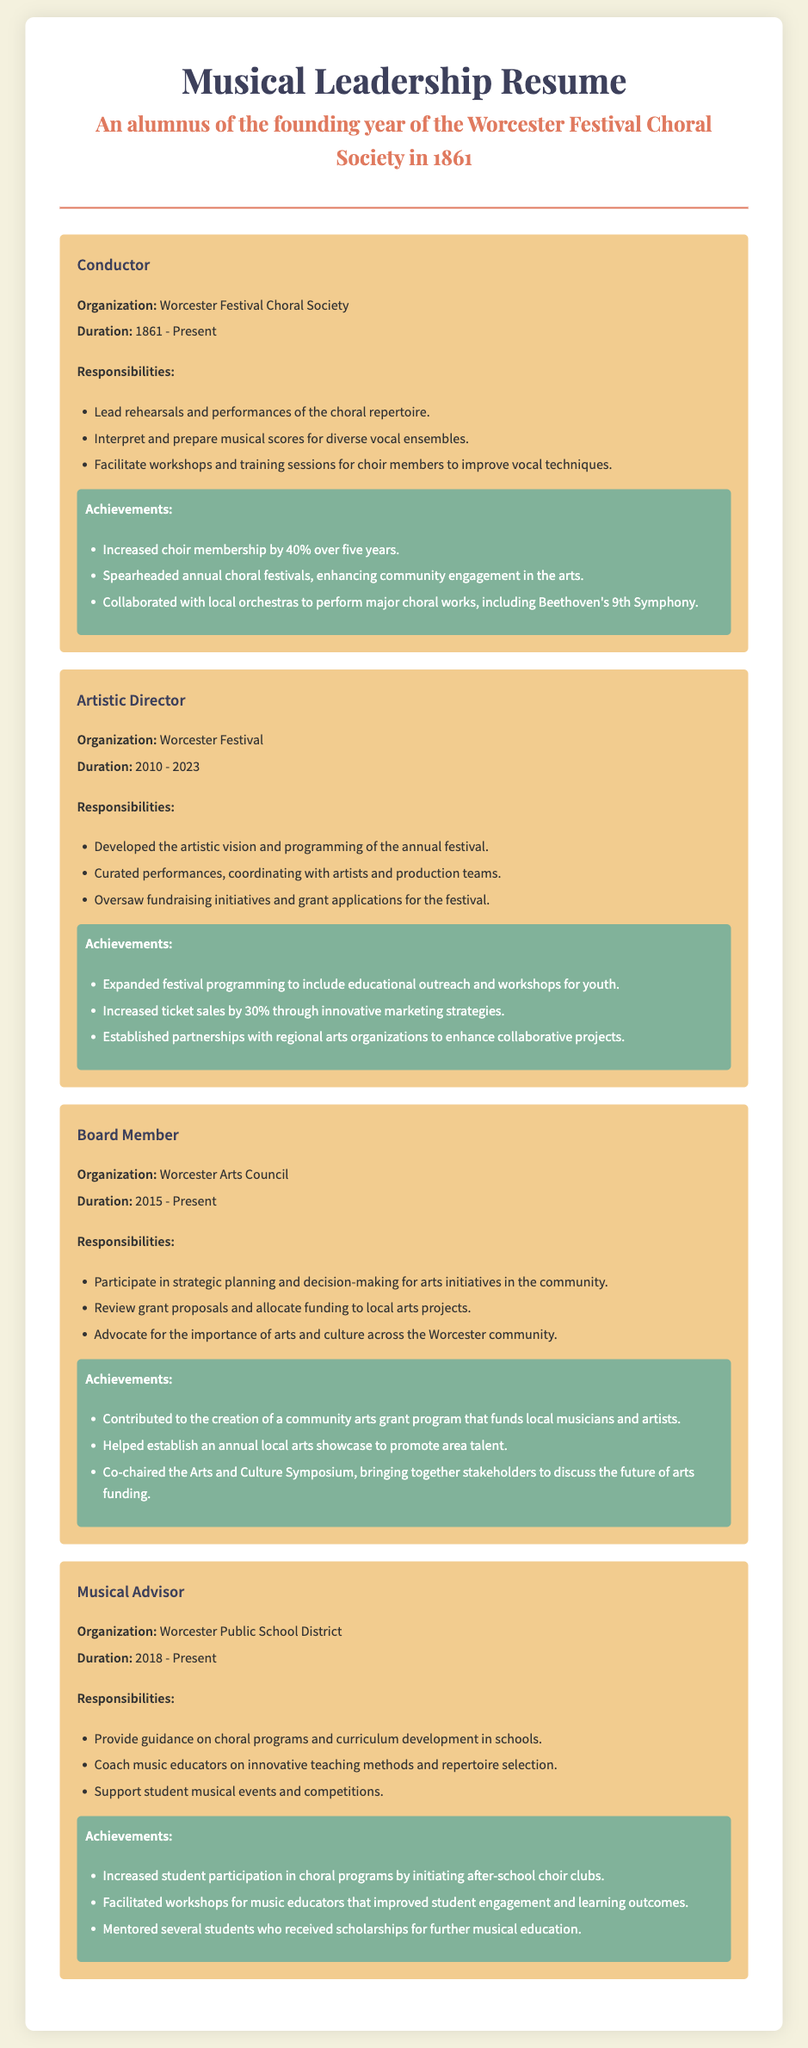What is the duration of the Conductor role? The duration of the Conductor role is stated as being from 1861 to Present in the document.
Answer: 1861 - Present What organization did the Artistic Director work for? The document specifies that the Artistic Director worked for the Worcester Festival.
Answer: Worcester Festival How much did the choir membership increase over five years? The document mentions that choir membership increased by 40% over five years as an achievement.
Answer: 40% What are two responsibilities of the Musical Advisor? To identify the responsibilities of the Musical Advisor, one can refer to the listed duties, such as providing guidance on choral programs and coaching music educators.
Answer: Provide guidance, Coach music educators What is one achievement of the Board Member role? The document lists contributions such as creating a community arts grant program as an achievement of the Board Member role.
Answer: Created a community arts grant program What years did the Artistic Director serve? The document provides the years of service for the Artistic Director role, which is from 2010 to 2023.
Answer: 2010 - 2023 What percentage increase in ticket sales was achieved for the festival? According to the document, ticket sales increased by 30% as a result of innovative marketing strategies.
Answer: 30% How many main choral works did the conductor collaborate on with local orchestras? The document mentions collaborating on major choral works, specifically citing Beethoven's 9th Symphony, indicating at least one collaboration.
Answer: Beethoven's 9th Symphony What type of events did the Musical Advisor support? The Musical Advisor provided support for student musical events and competitions as listed in the responsibilities.
Answer: Student musical events What is the color used for the achievements section in the roles? The document specifies that the achievements section has a greenish background color.
Answer: Greenish 